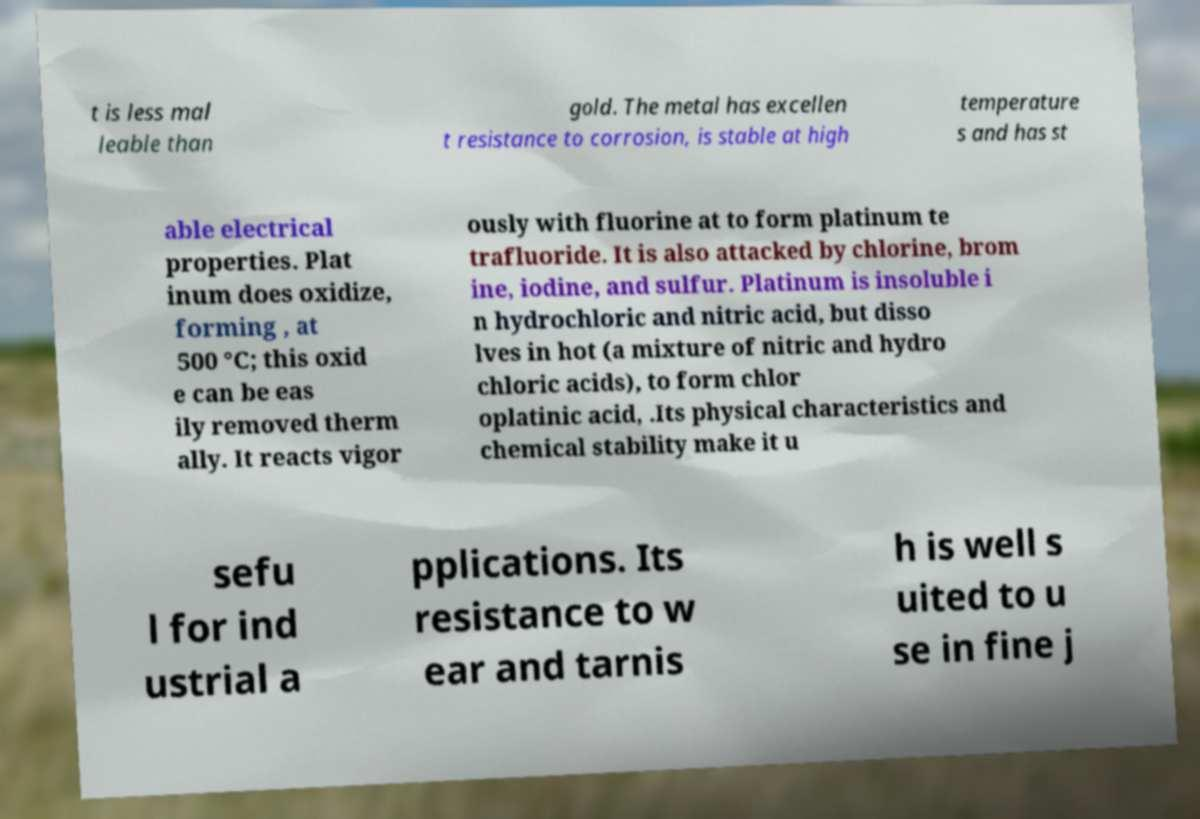What messages or text are displayed in this image? I need them in a readable, typed format. t is less mal leable than gold. The metal has excellen t resistance to corrosion, is stable at high temperature s and has st able electrical properties. Plat inum does oxidize, forming , at 500 °C; this oxid e can be eas ily removed therm ally. It reacts vigor ously with fluorine at to form platinum te trafluoride. It is also attacked by chlorine, brom ine, iodine, and sulfur. Platinum is insoluble i n hydrochloric and nitric acid, but disso lves in hot (a mixture of nitric and hydro chloric acids), to form chlor oplatinic acid, .Its physical characteristics and chemical stability make it u sefu l for ind ustrial a pplications. Its resistance to w ear and tarnis h is well s uited to u se in fine j 